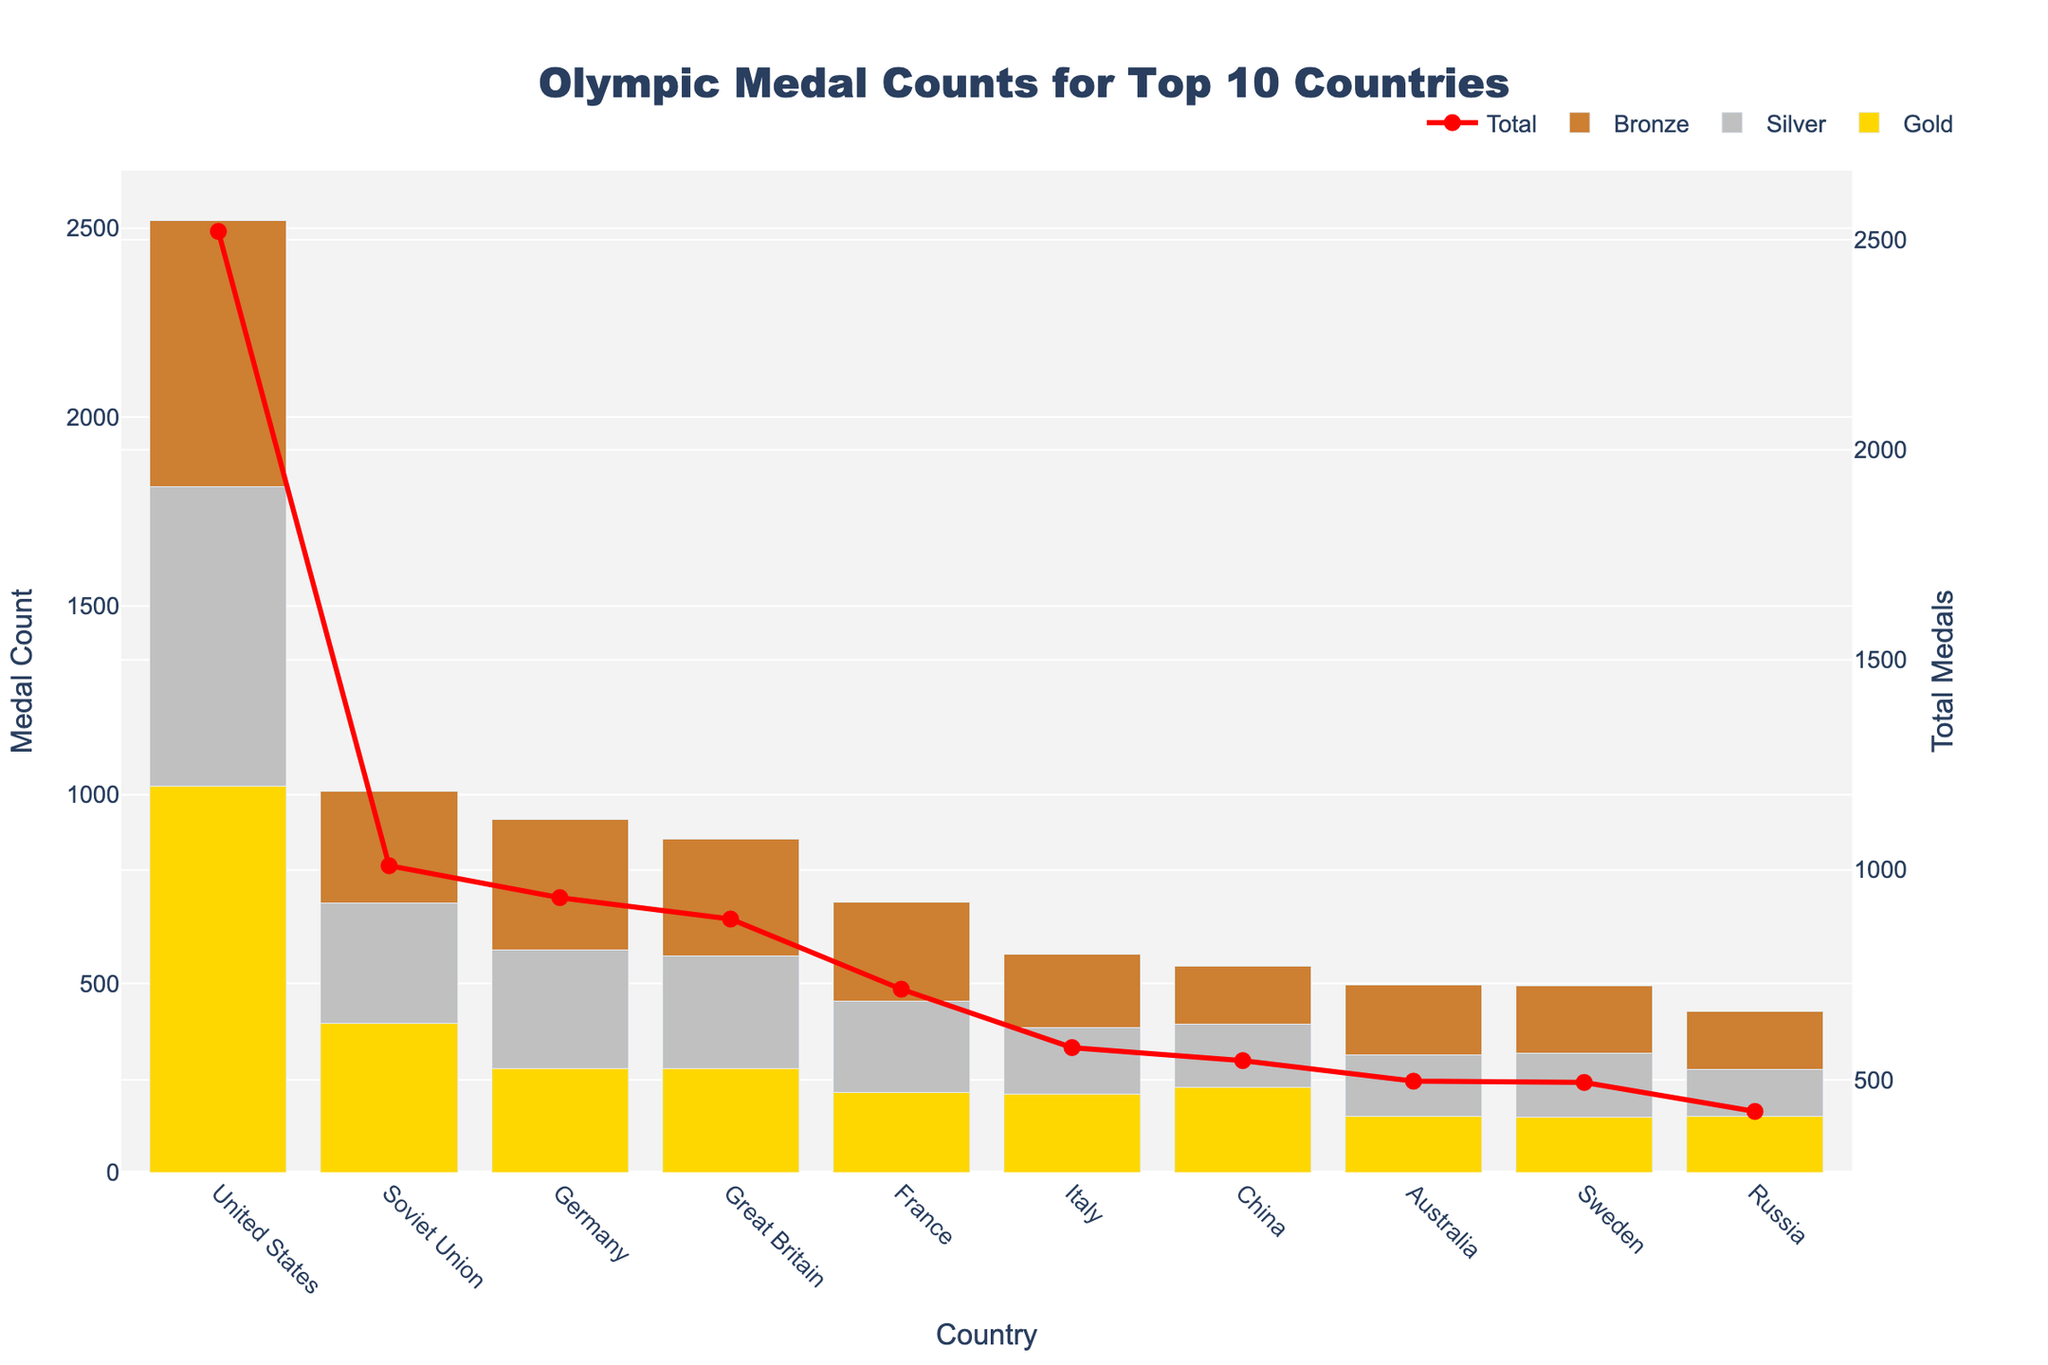Which country has the highest number of gold medals? The bar for gold medals is the highest for the United States, indicating they have the highest number of gold medals.
Answer: United States How many more silver medals does Great Britain have compared to Italy? Great Britain has 299 silver medals, and Italy has 178 silver medals. The difference is 299 - 178 = 121.
Answer: 121 Which countries have fewer than 300 bronze medals? The bars representing bronze medals for Soviet Union, Germany, Great Britain, and France exceed 300, while United States, Italy, China, Australia, Sweden, and Russia have fewer than 300 bronze medals.
Answer: United States, Italy, China, Australia, Sweden, Russia What is the total number of medals for China? The total medals for China is the sum of its gold, silver, and bronze medals, which are 224, 167, and 155 respectively. So, the total is 224 + 167 + 155 = 546.
Answer: 546 Among the top 10 countries, which country has the lowest total number of medals? From the line plot in red, Russia has the lowest point, indicating it has the lowest total number of medals.
Answer: Russia How many gold and silver medals combined does Germany have? Germany has 275 gold medals and 313 silver medals. Their combined total is 275 + 313 = 588.
Answer: 588 Which country has the second-highest number of gold medals? The bar representing gold medals is highest for the United States and second highest for the Soviet Union.
Answer: Soviet Union Which country has more bronze medals, Australia or Sweden? The bar for bronze medals is higher for Australia compared to Sweden.
Answer: Australia Are there any countries with an equal number of gold and silver medals? By comparing the heights of the gold and silver bars, it is clear that no country has equal numbers of gold and silver medals.
Answer: No 